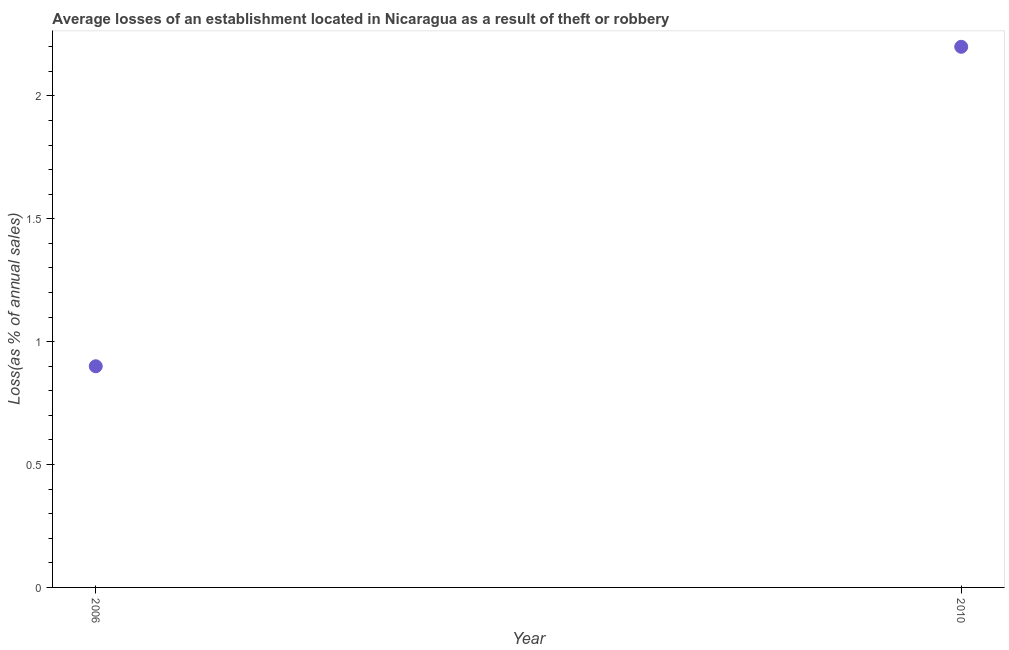Across all years, what is the maximum losses due to theft?
Your response must be concise. 2.2. In which year was the losses due to theft maximum?
Provide a short and direct response. 2010. What is the sum of the losses due to theft?
Your answer should be very brief. 3.1. What is the difference between the losses due to theft in 2006 and 2010?
Give a very brief answer. -1.3. What is the average losses due to theft per year?
Your answer should be compact. 1.55. What is the median losses due to theft?
Offer a terse response. 1.55. In how many years, is the losses due to theft greater than 1.6 %?
Your answer should be compact. 1. What is the ratio of the losses due to theft in 2006 to that in 2010?
Ensure brevity in your answer.  0.41. Does the losses due to theft monotonically increase over the years?
Your answer should be compact. Yes. How many dotlines are there?
Your answer should be compact. 1. How many years are there in the graph?
Provide a short and direct response. 2. Are the values on the major ticks of Y-axis written in scientific E-notation?
Offer a terse response. No. Does the graph contain any zero values?
Make the answer very short. No. What is the title of the graph?
Provide a succinct answer. Average losses of an establishment located in Nicaragua as a result of theft or robbery. What is the label or title of the Y-axis?
Your answer should be compact. Loss(as % of annual sales). What is the Loss(as % of annual sales) in 2006?
Your response must be concise. 0.9. What is the difference between the Loss(as % of annual sales) in 2006 and 2010?
Make the answer very short. -1.3. What is the ratio of the Loss(as % of annual sales) in 2006 to that in 2010?
Keep it short and to the point. 0.41. 